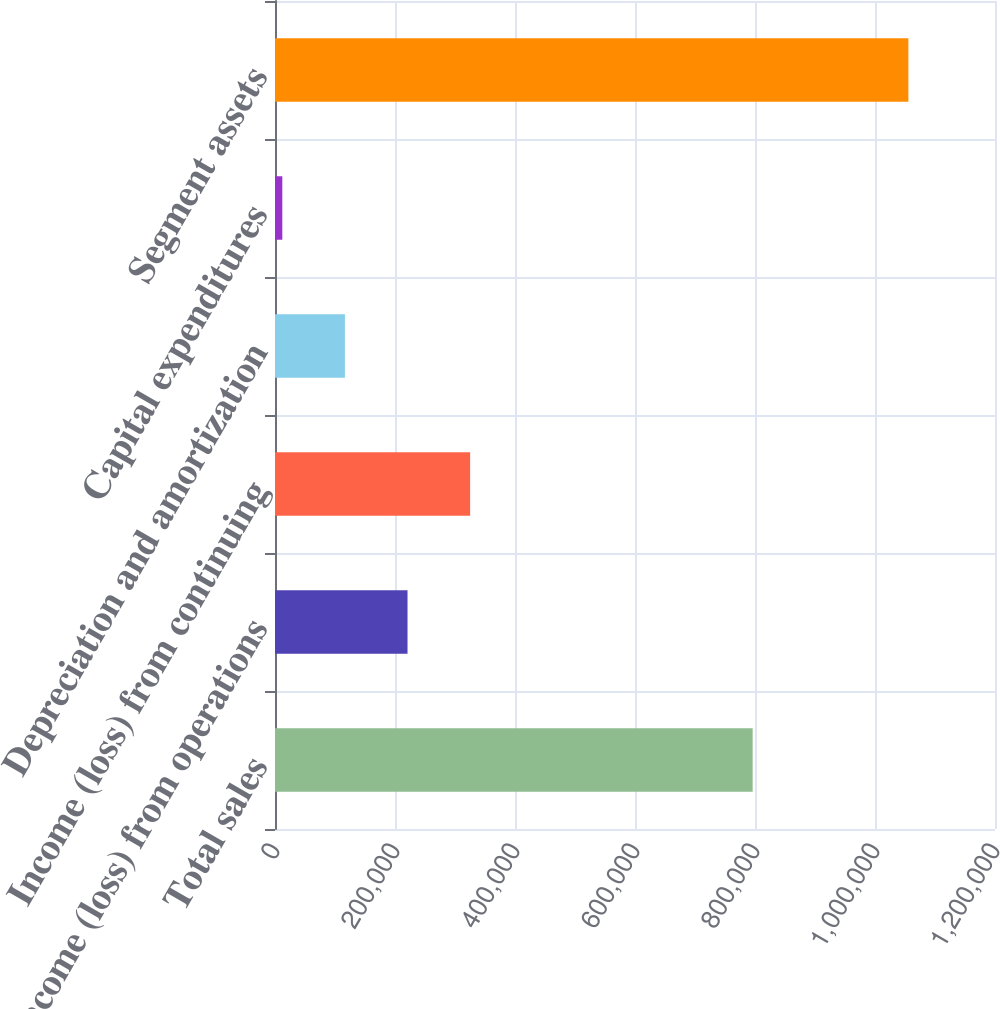Convert chart. <chart><loc_0><loc_0><loc_500><loc_500><bar_chart><fcel>Total sales<fcel>Income (loss) from operations<fcel>Income (loss) from continuing<fcel>Depreciation and amortization<fcel>Capital expenditures<fcel>Segment assets<nl><fcel>796081<fcel>220867<fcel>325211<fcel>116522<fcel>12178<fcel>1.05562e+06<nl></chart> 